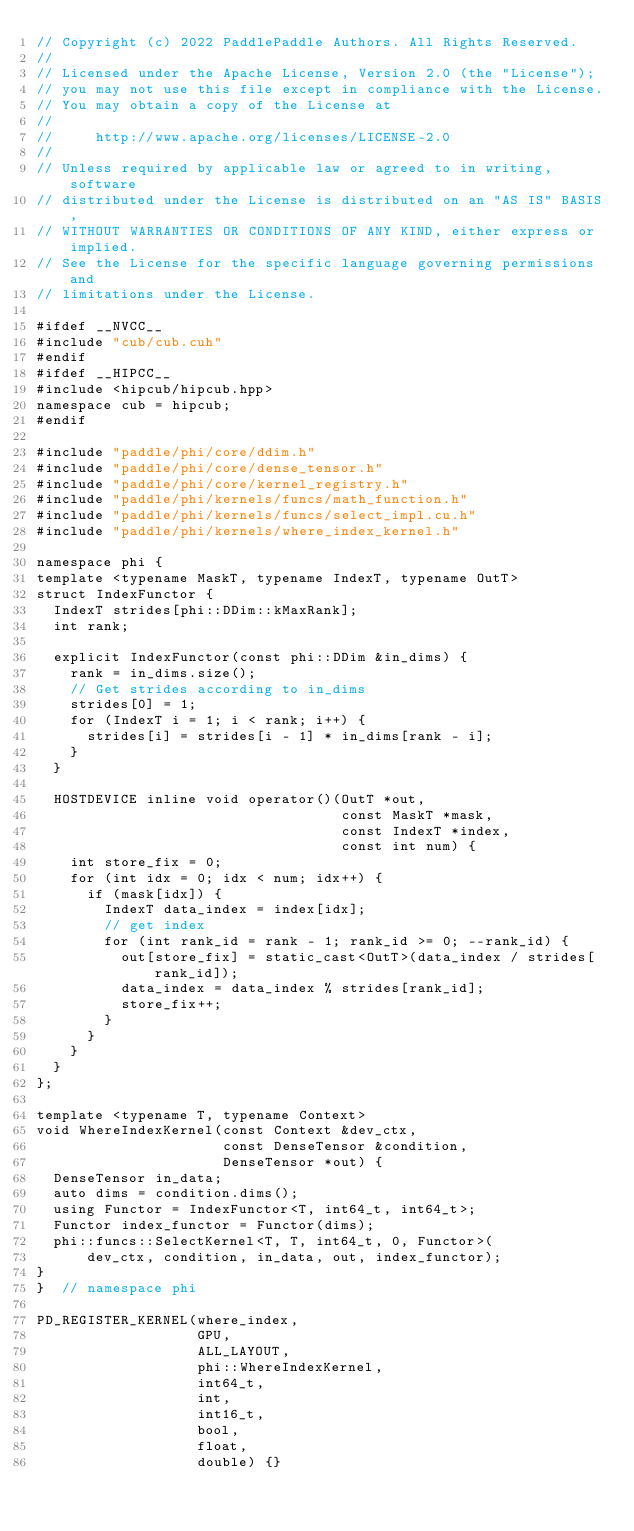<code> <loc_0><loc_0><loc_500><loc_500><_Cuda_>// Copyright (c) 2022 PaddlePaddle Authors. All Rights Reserved.
//
// Licensed under the Apache License, Version 2.0 (the "License");
// you may not use this file except in compliance with the License.
// You may obtain a copy of the License at
//
//     http://www.apache.org/licenses/LICENSE-2.0
//
// Unless required by applicable law or agreed to in writing, software
// distributed under the License is distributed on an "AS IS" BASIS,
// WITHOUT WARRANTIES OR CONDITIONS OF ANY KIND, either express or implied.
// See the License for the specific language governing permissions and
// limitations under the License.

#ifdef __NVCC__
#include "cub/cub.cuh"
#endif
#ifdef __HIPCC__
#include <hipcub/hipcub.hpp>
namespace cub = hipcub;
#endif

#include "paddle/phi/core/ddim.h"
#include "paddle/phi/core/dense_tensor.h"
#include "paddle/phi/core/kernel_registry.h"
#include "paddle/phi/kernels/funcs/math_function.h"
#include "paddle/phi/kernels/funcs/select_impl.cu.h"
#include "paddle/phi/kernels/where_index_kernel.h"

namespace phi {
template <typename MaskT, typename IndexT, typename OutT>
struct IndexFunctor {
  IndexT strides[phi::DDim::kMaxRank];
  int rank;

  explicit IndexFunctor(const phi::DDim &in_dims) {
    rank = in_dims.size();
    // Get strides according to in_dims
    strides[0] = 1;
    for (IndexT i = 1; i < rank; i++) {
      strides[i] = strides[i - 1] * in_dims[rank - i];
    }
  }

  HOSTDEVICE inline void operator()(OutT *out,
                                    const MaskT *mask,
                                    const IndexT *index,
                                    const int num) {
    int store_fix = 0;
    for (int idx = 0; idx < num; idx++) {
      if (mask[idx]) {
        IndexT data_index = index[idx];
        // get index
        for (int rank_id = rank - 1; rank_id >= 0; --rank_id) {
          out[store_fix] = static_cast<OutT>(data_index / strides[rank_id]);
          data_index = data_index % strides[rank_id];
          store_fix++;
        }
      }
    }
  }
};

template <typename T, typename Context>
void WhereIndexKernel(const Context &dev_ctx,
                      const DenseTensor &condition,
                      DenseTensor *out) {
  DenseTensor in_data;
  auto dims = condition.dims();
  using Functor = IndexFunctor<T, int64_t, int64_t>;
  Functor index_functor = Functor(dims);
  phi::funcs::SelectKernel<T, T, int64_t, 0, Functor>(
      dev_ctx, condition, in_data, out, index_functor);
}
}  // namespace phi

PD_REGISTER_KERNEL(where_index,
                   GPU,
                   ALL_LAYOUT,
                   phi::WhereIndexKernel,
                   int64_t,
                   int,
                   int16_t,
                   bool,
                   float,
                   double) {}
</code> 